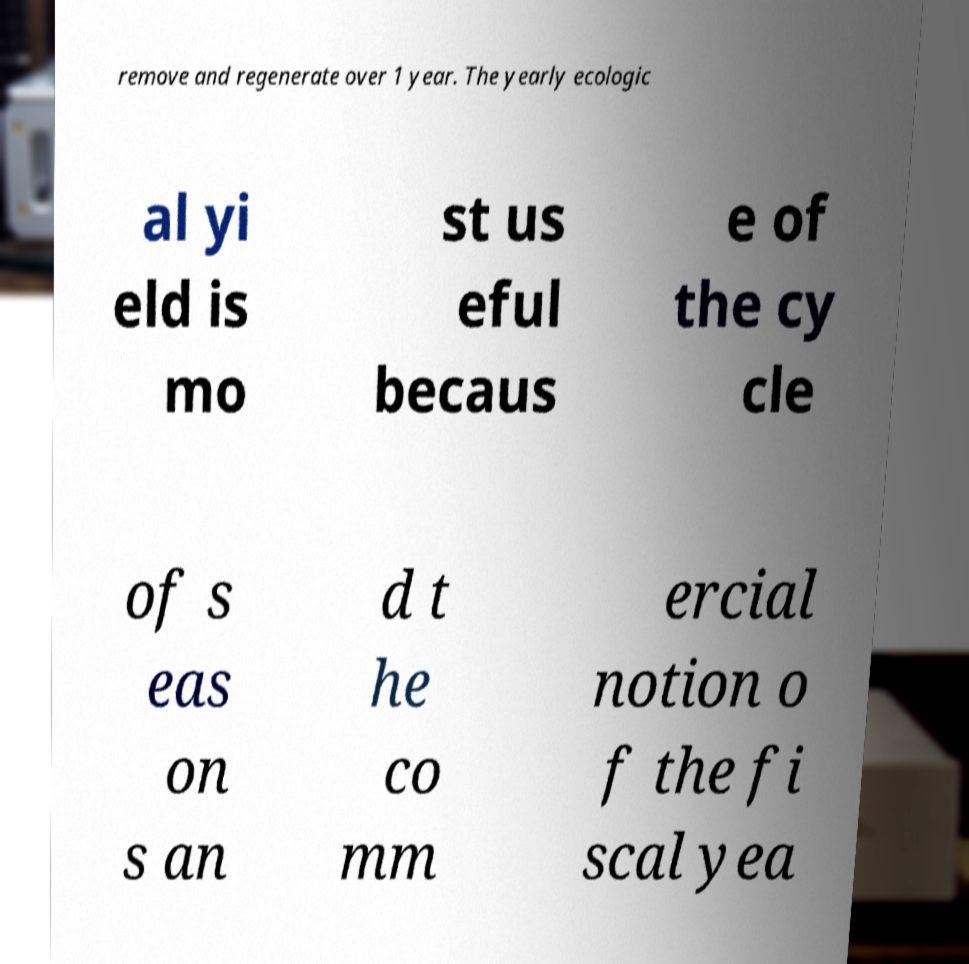What messages or text are displayed in this image? I need them in a readable, typed format. remove and regenerate over 1 year. The yearly ecologic al yi eld is mo st us eful becaus e of the cy cle of s eas on s an d t he co mm ercial notion o f the fi scal yea 